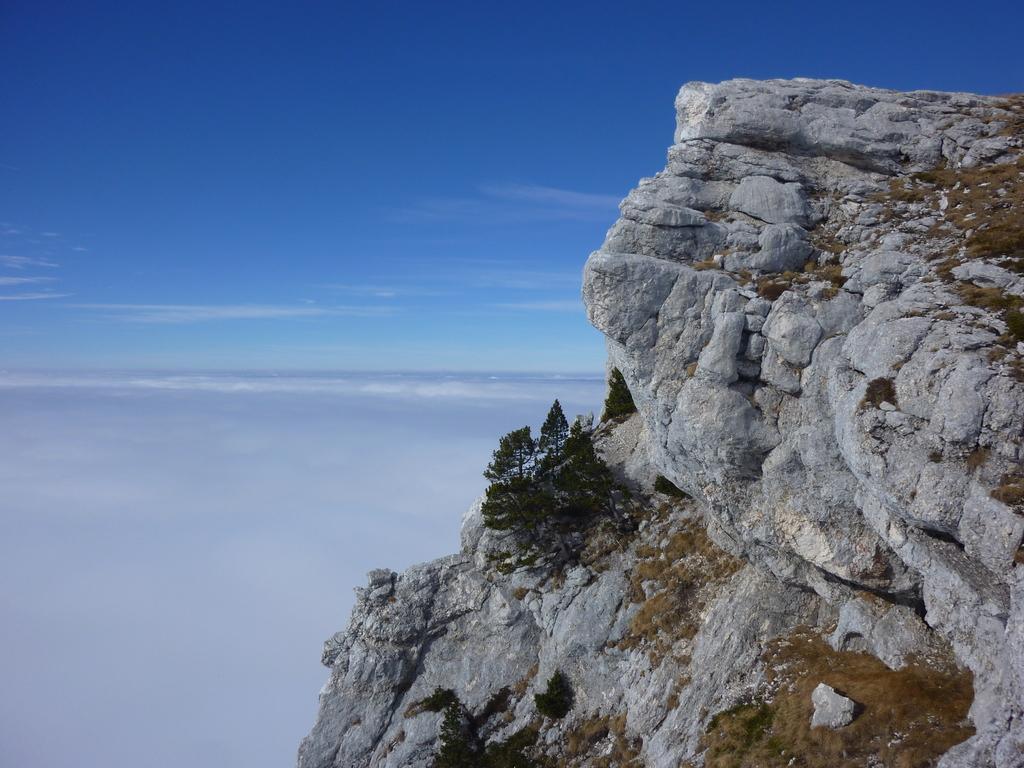How would you summarize this image in a sentence or two? In this picture we can see huge rocks with plants on the right side & on the left side, we can see clouds and blue sky. 